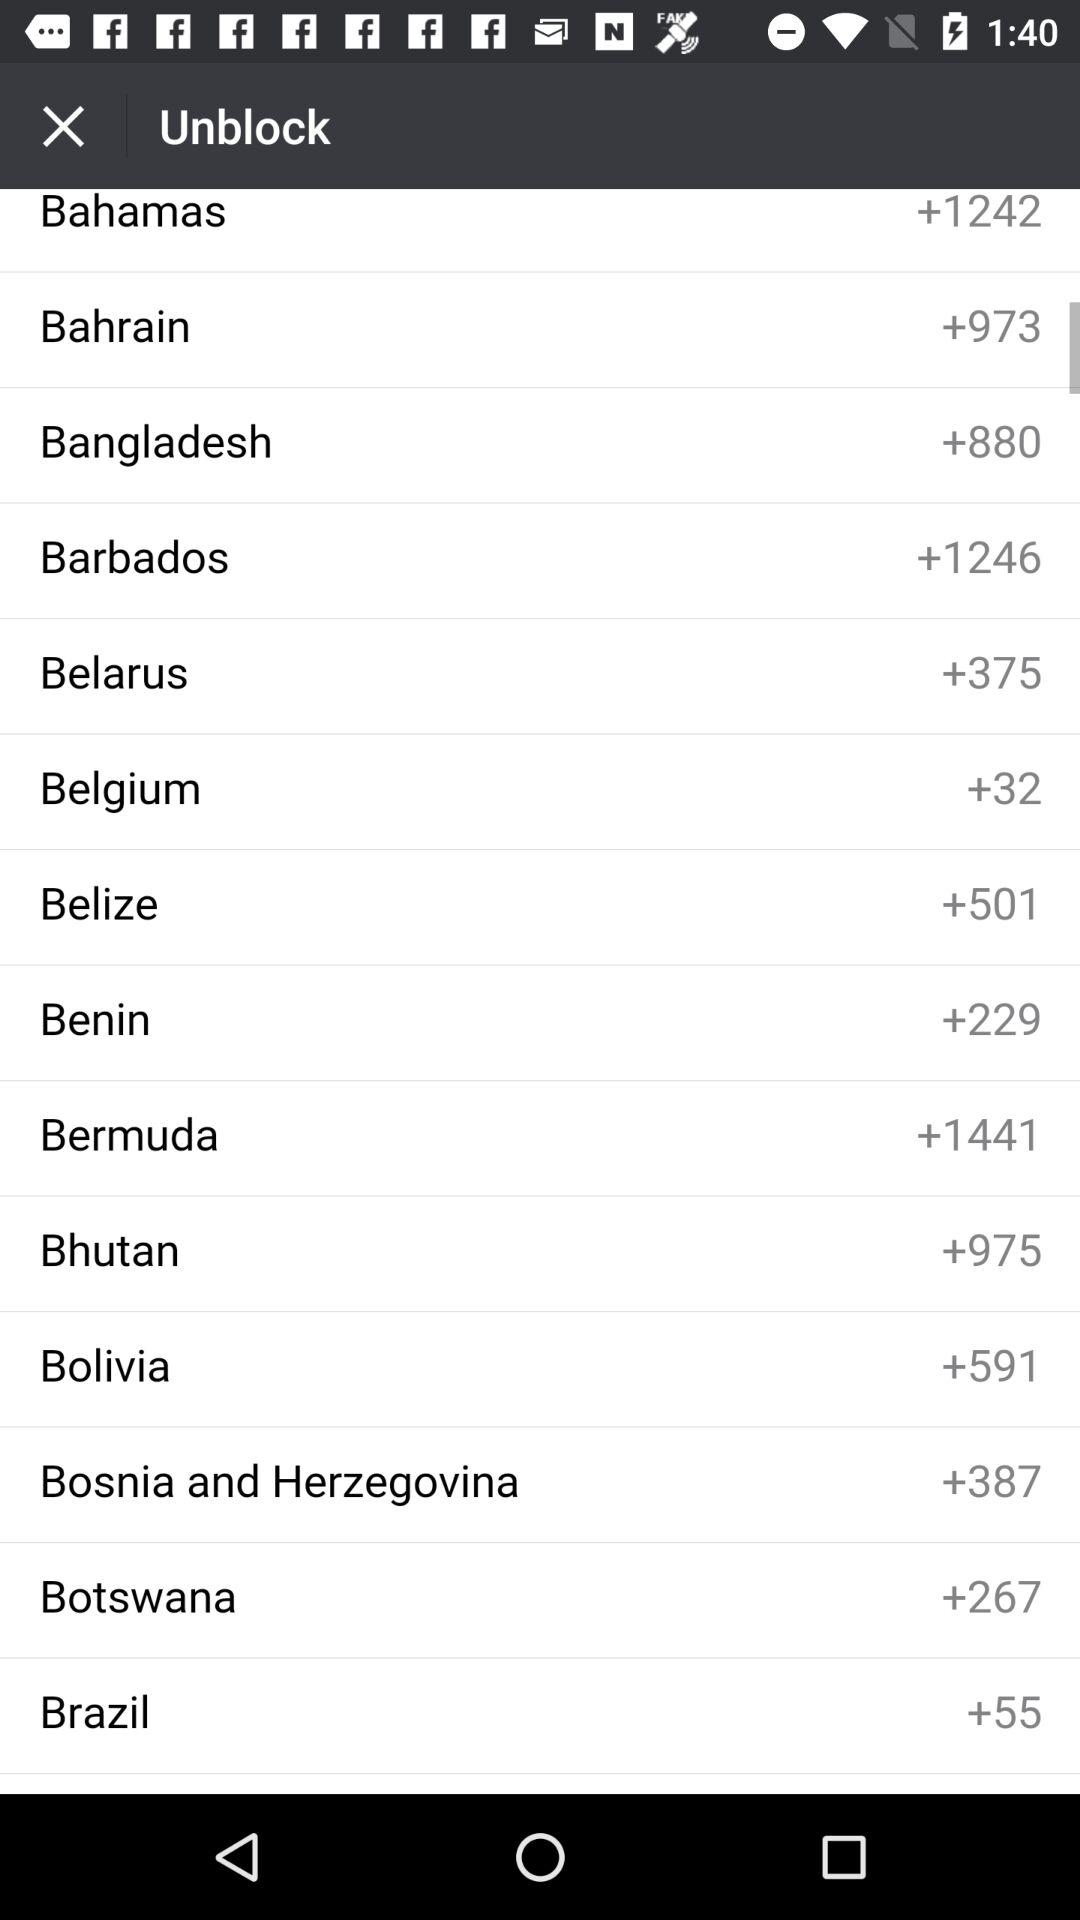What is the country code for Bangladesh? The country code is +880. 